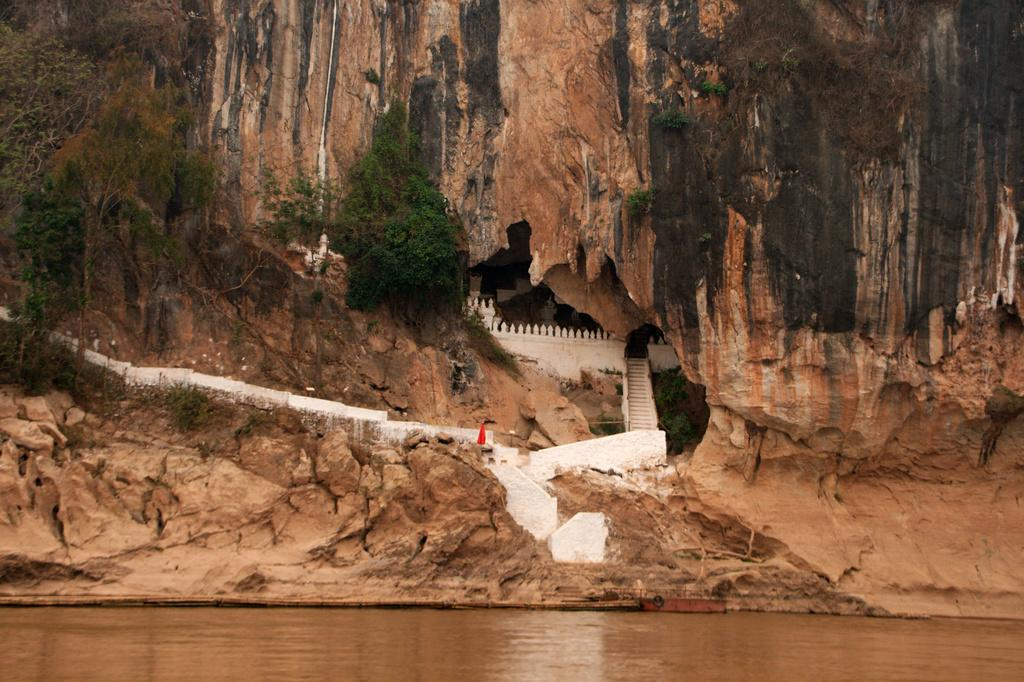What is located at the front of the image? There is a lake in the front of the image. What can be seen in the background of the image? There is a mountain in the background of the image. What feature is present on the mountain? There are steps in the middle of the mountain. What type of vegetation is on the left side of the mountain? There are trees on the left side of the mountain. Can you read the caption on the goat's eye in the image? There is no goat or caption present in the image. 